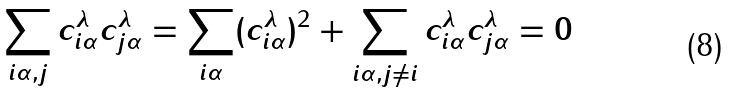Convert formula to latex. <formula><loc_0><loc_0><loc_500><loc_500>\sum _ { i \alpha , j } c _ { i \alpha } ^ { \lambda } c _ { j \alpha } ^ { \lambda } = \sum _ { i \alpha } ( c _ { i \alpha } ^ { \lambda } ) ^ { 2 } + \sum _ { i \alpha , j \ne i } c _ { i \alpha } ^ { \lambda } c _ { j \alpha } ^ { \lambda } = 0</formula> 